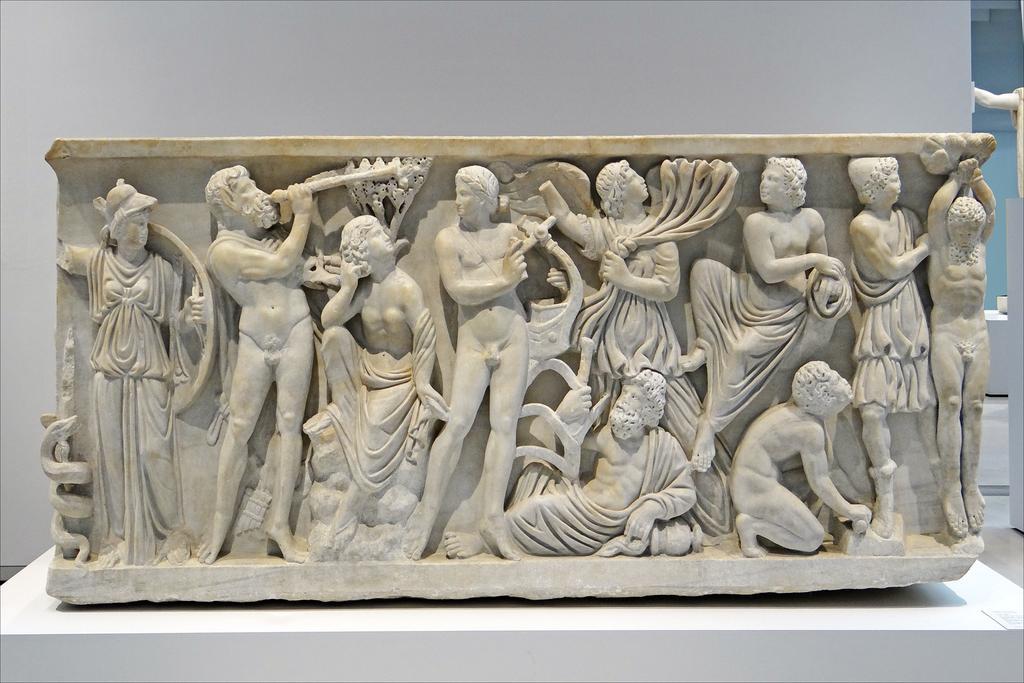Could you give a brief overview of what you see in this image? In this image I can see number of sculptures on a white colour thing. On the right side of this image I can see one more sculpture. 